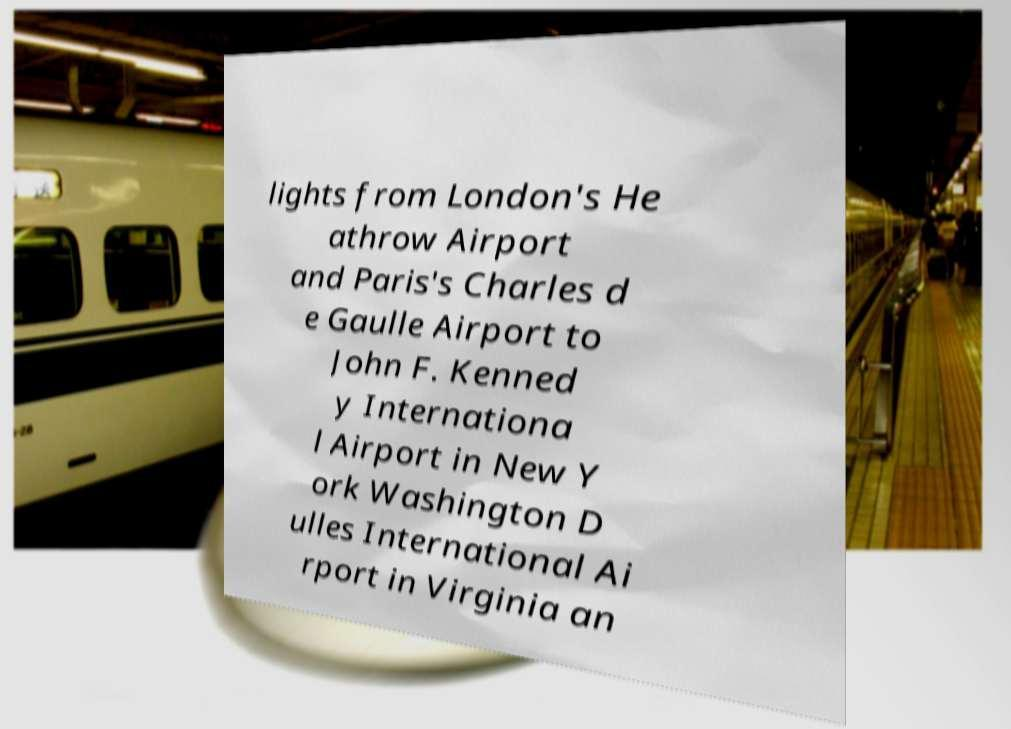There's text embedded in this image that I need extracted. Can you transcribe it verbatim? lights from London's He athrow Airport and Paris's Charles d e Gaulle Airport to John F. Kenned y Internationa l Airport in New Y ork Washington D ulles International Ai rport in Virginia an 